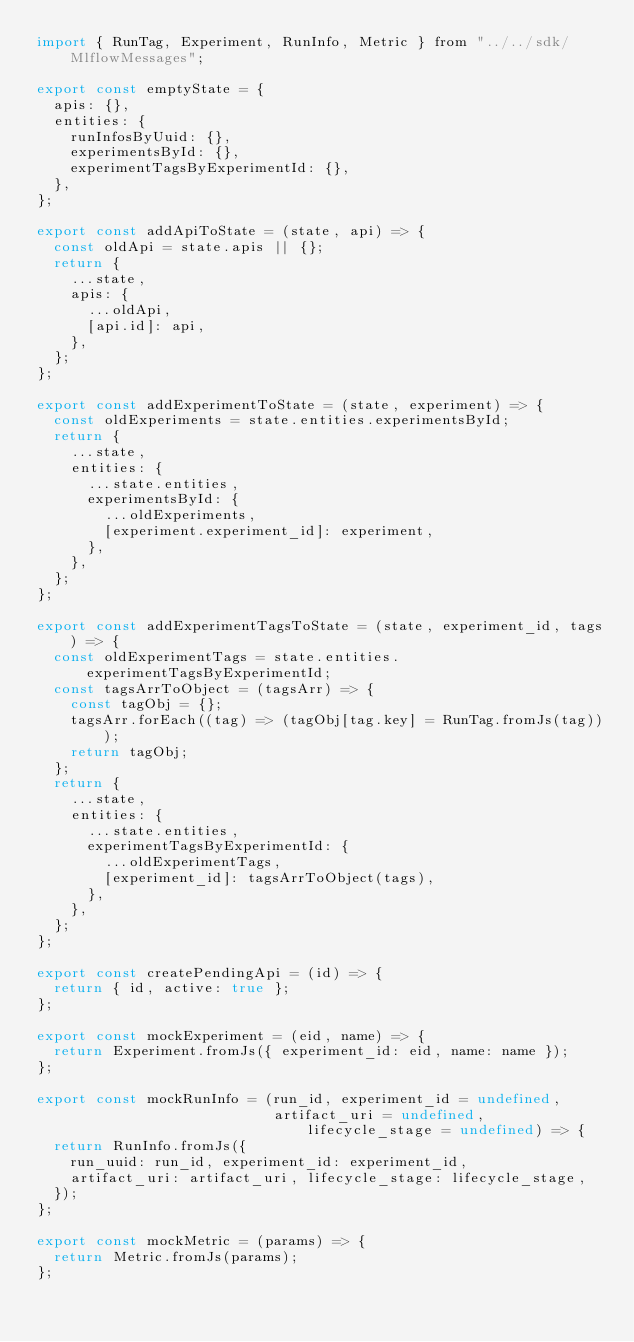Convert code to text. <code><loc_0><loc_0><loc_500><loc_500><_JavaScript_>import { RunTag, Experiment, RunInfo, Metric } from "../../sdk/MlflowMessages";

export const emptyState = {
  apis: {},
  entities: {
    runInfosByUuid: {},
    experimentsById: {},
    experimentTagsByExperimentId: {},
  },
};

export const addApiToState = (state, api) => {
  const oldApi = state.apis || {};
  return {
    ...state,
    apis: {
      ...oldApi,
      [api.id]: api,
    },
  };
};

export const addExperimentToState = (state, experiment) => {
  const oldExperiments = state.entities.experimentsById;
  return {
    ...state,
    entities: {
      ...state.entities,
      experimentsById: {
        ...oldExperiments,
        [experiment.experiment_id]: experiment,
      },
    },
  };
};

export const addExperimentTagsToState = (state, experiment_id, tags) => {
  const oldExperimentTags = state.entities.experimentTagsByExperimentId;
  const tagsArrToObject = (tagsArr) => {
    const tagObj = {};
    tagsArr.forEach((tag) => (tagObj[tag.key] = RunTag.fromJs(tag)));
    return tagObj;
  };
  return {
    ...state,
    entities: {
      ...state.entities,
      experimentTagsByExperimentId: {
        ...oldExperimentTags,
        [experiment_id]: tagsArrToObject(tags),
      },
    },
  };
};

export const createPendingApi = (id) => {
  return { id, active: true };
};

export const mockExperiment = (eid, name) => {
  return Experiment.fromJs({ experiment_id: eid, name: name });
};

export const mockRunInfo = (run_id, experiment_id = undefined,
                            artifact_uri = undefined, lifecycle_stage = undefined) => {
  return RunInfo.fromJs({
    run_uuid: run_id, experiment_id: experiment_id,
    artifact_uri: artifact_uri, lifecycle_stage: lifecycle_stage,
  });
};

export const mockMetric = (params) => {
  return Metric.fromJs(params);
};

</code> 